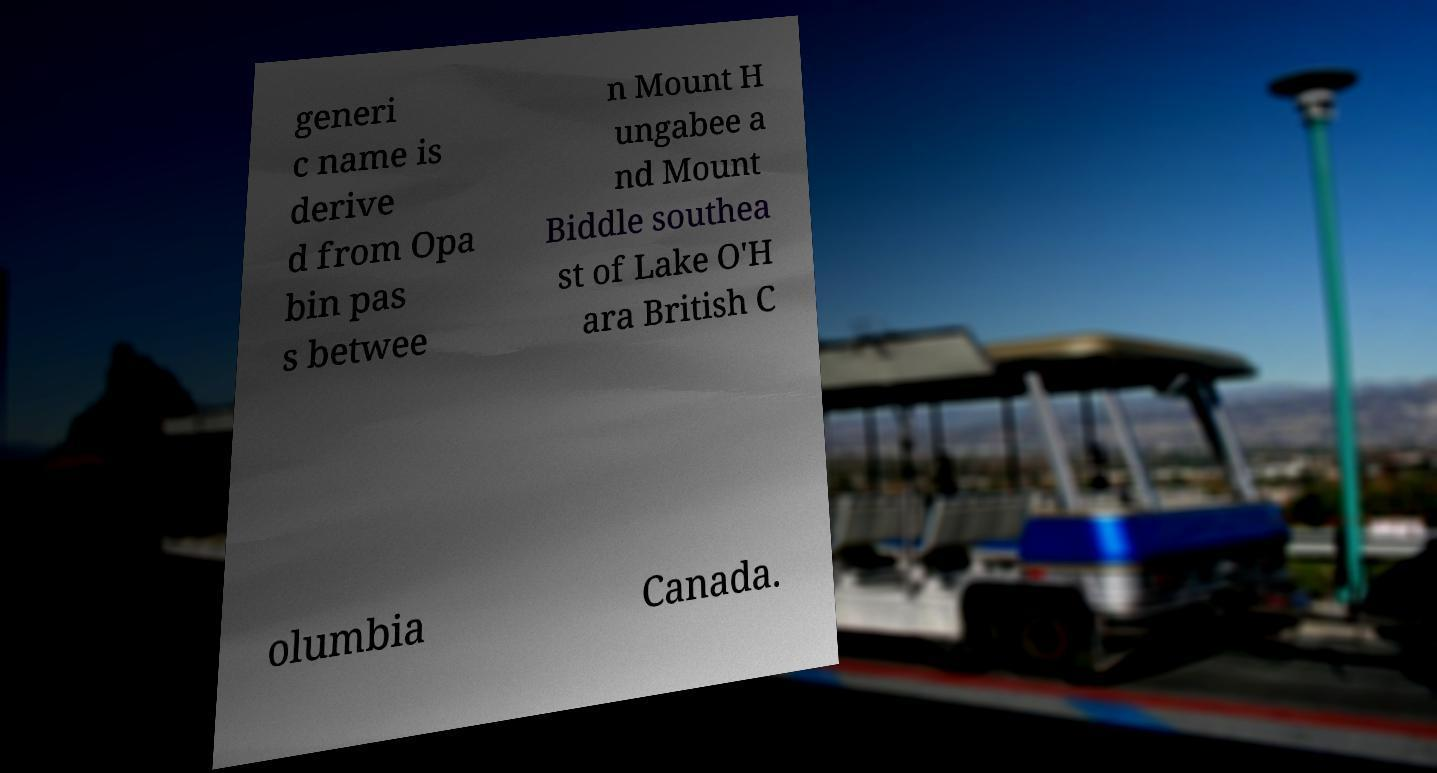Can you accurately transcribe the text from the provided image for me? generi c name is derive d from Opa bin pas s betwee n Mount H ungabee a nd Mount Biddle southea st of Lake O'H ara British C olumbia Canada. 